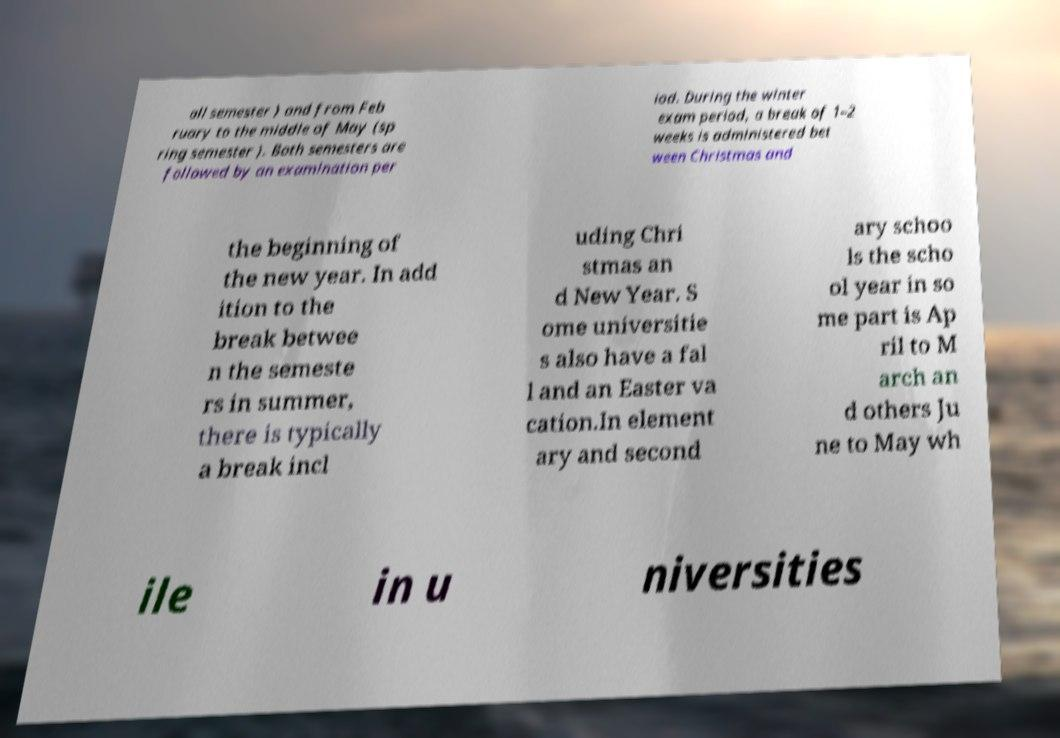There's text embedded in this image that I need extracted. Can you transcribe it verbatim? all semester ) and from Feb ruary to the middle of May (sp ring semester ). Both semesters are followed by an examination per iod. During the winter exam period, a break of 1–2 weeks is administered bet ween Christmas and the beginning of the new year. In add ition to the break betwee n the semeste rs in summer, there is typically a break incl uding Chri stmas an d New Year. S ome universitie s also have a fal l and an Easter va cation.In element ary and second ary schoo ls the scho ol year in so me part is Ap ril to M arch an d others Ju ne to May wh ile in u niversities 